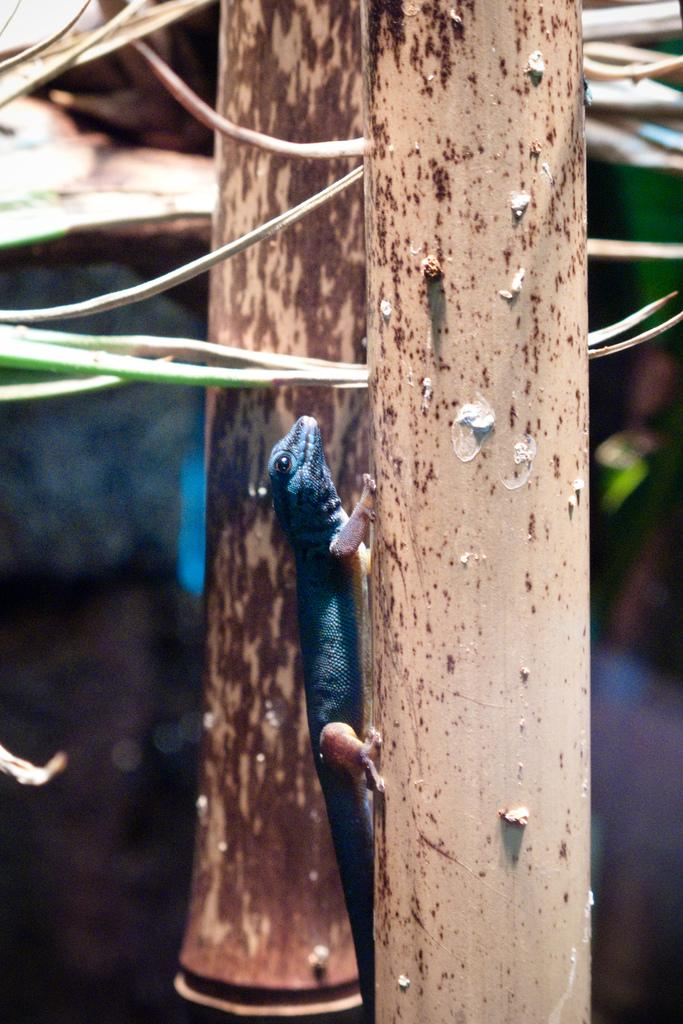What objects can be seen in the image that are made of iron? There are two iron rods in the image. What type of animal is present in the image? There is a black color lizard in the image. What is the lizard doing in the image? The lizard is climbing. How many clocks can be seen hanging on the iron rods in the image? There are no clocks present in the image; it only features two iron rods and a black color lizard. 